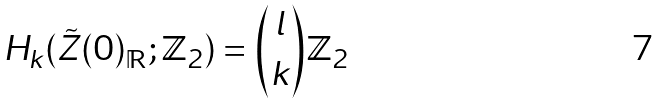Convert formula to latex. <formula><loc_0><loc_0><loc_500><loc_500>H _ { k } ( \tilde { Z } ( 0 ) _ { \mathbb { R } } ; { \mathbb { Z } } _ { 2 } ) = { \binom { l } { k } { \mathbb { Z } } _ { 2 } }</formula> 